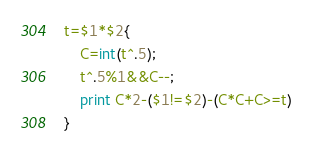<code> <loc_0><loc_0><loc_500><loc_500><_Awk_>t=$1*$2{
	C=int(t^.5);
    t^.5%1&&C--;
	print C*2-($1!=$2)-(C*C+C>=t)
}</code> 